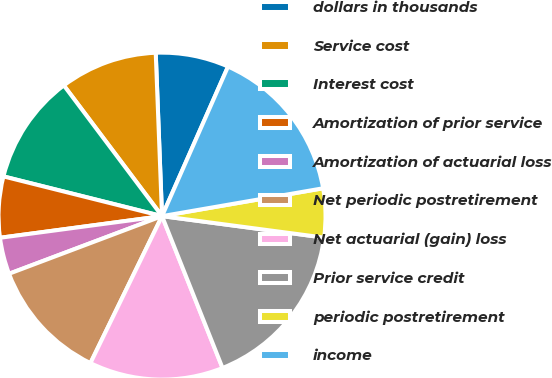<chart> <loc_0><loc_0><loc_500><loc_500><pie_chart><fcel>dollars in thousands<fcel>Service cost<fcel>Interest cost<fcel>Amortization of prior service<fcel>Amortization of actuarial loss<fcel>Net periodic postretirement<fcel>Net actuarial (gain) loss<fcel>Prior service credit<fcel>periodic postretirement<fcel>income<nl><fcel>7.23%<fcel>9.64%<fcel>10.84%<fcel>6.02%<fcel>3.62%<fcel>12.05%<fcel>13.25%<fcel>16.87%<fcel>4.82%<fcel>15.66%<nl></chart> 